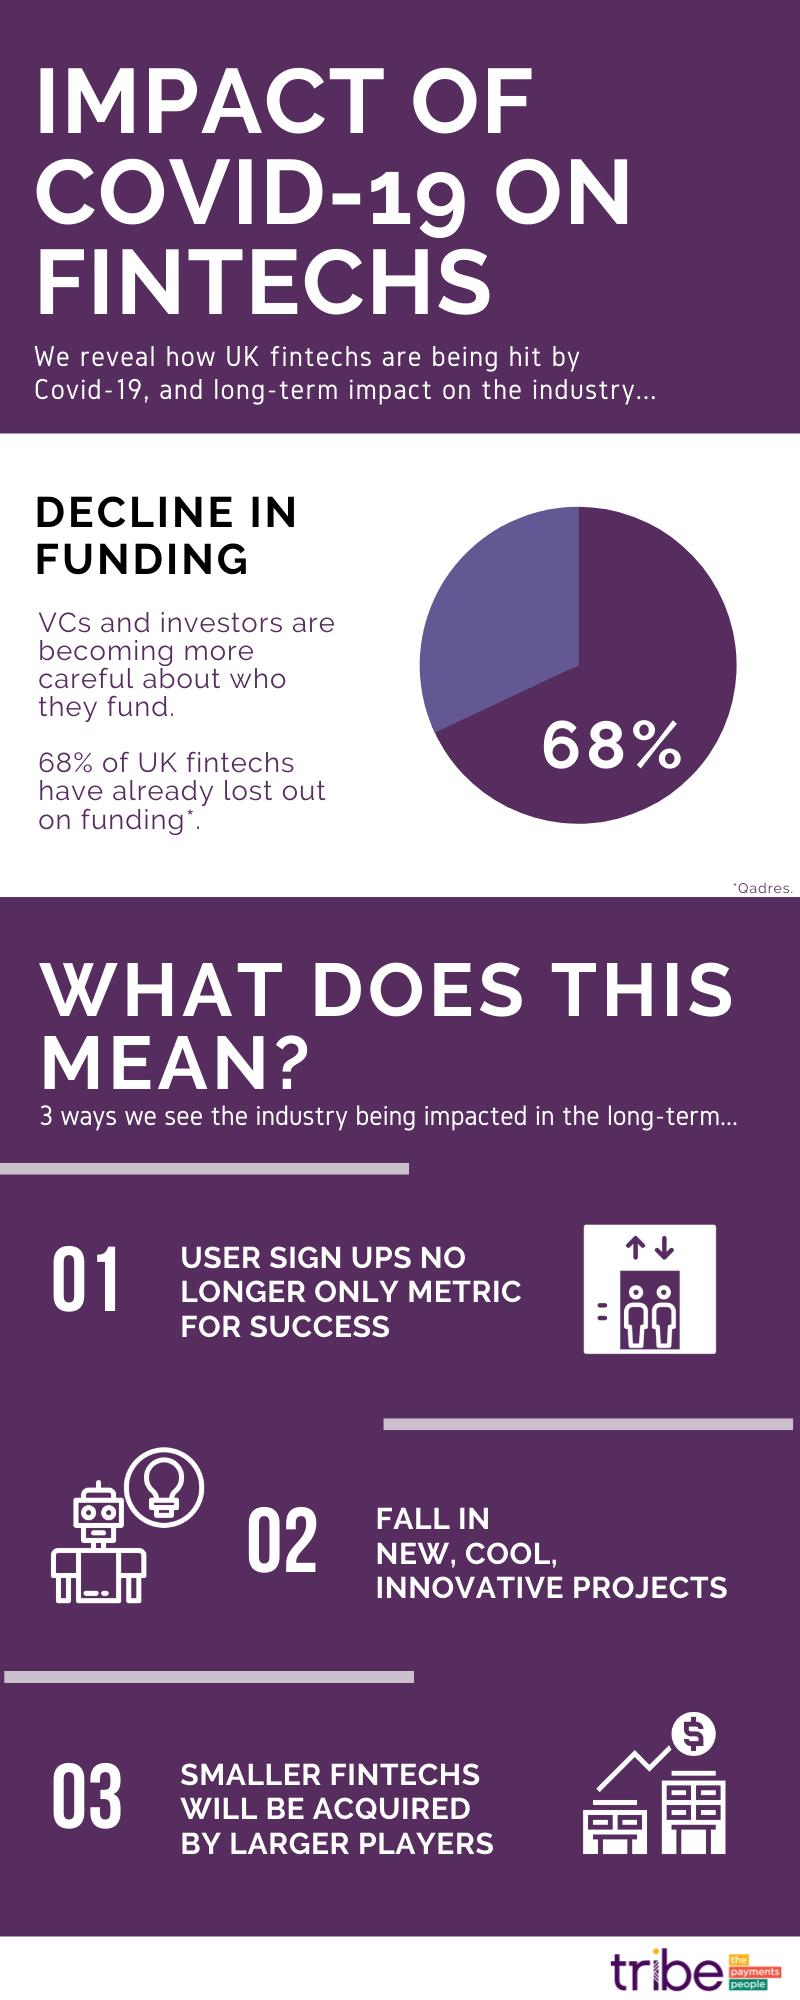Outline some significant characteristics in this image. Smaller fintechs will be acquired by larger players, as indicated by the challenge posed by the buildings and currency symbols. The robot and light bulb suggest a challenge to embrace new, cool, and innovative projects, indicating a call to action to explore and pursue cutting-edge ideas. A significant proportion of fintechs still have funding, with 32% of them remaining unfunded. 